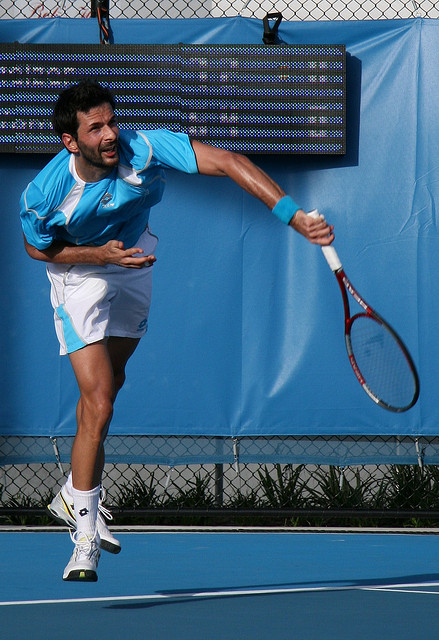<image>What brand are the socks? I'm not sure what brand the socks are. It could be 'Under Armour', 'Champion', 'Adidas', 'Polo', 'Andi' or 'Asics'. What brand are the socks? I am not sure what brand the socks are. It can be 'under armour', 'champion', 'adidas', 'polo', 'andi' or 'asics'. 